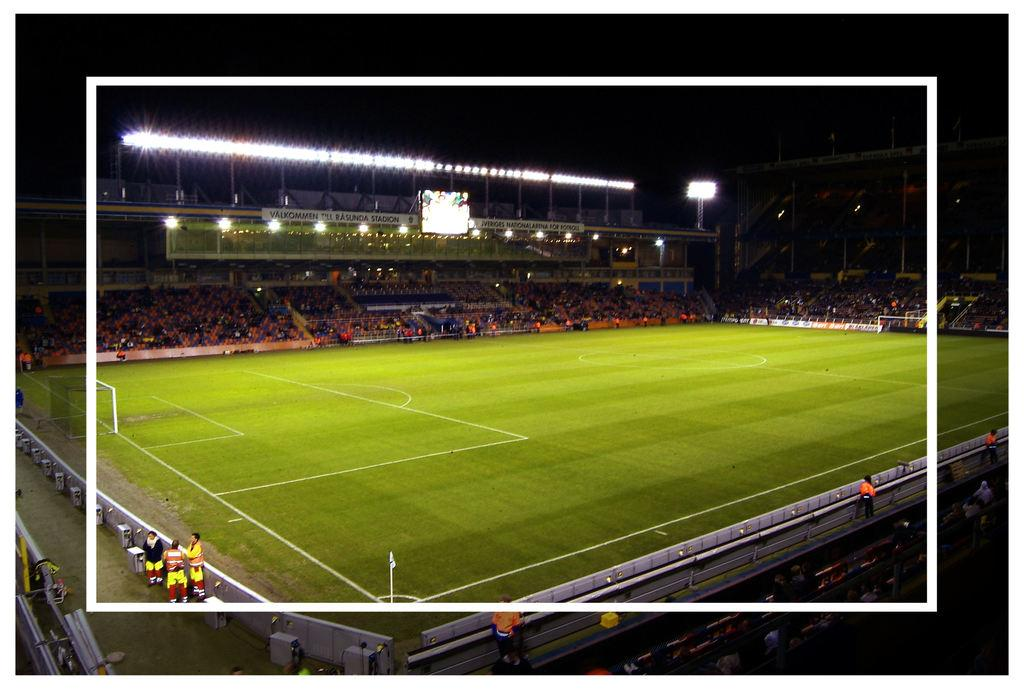What type of structure is shown in the image? There is a stadium in the image. Can you describe the people inside the stadium? Spectators are present on different floors of the stadium. What can be seen in terms of lighting in the image? Lights are visible in the image. What type of display is present in the stadium? There is a screen in the image. How was the image captured or modified? The image has an edited frame. What is the opinion of the nerve on the base in the image? There is no nerve or base present in the image; it is a picture of a stadium with spectators, lights and a screen. 